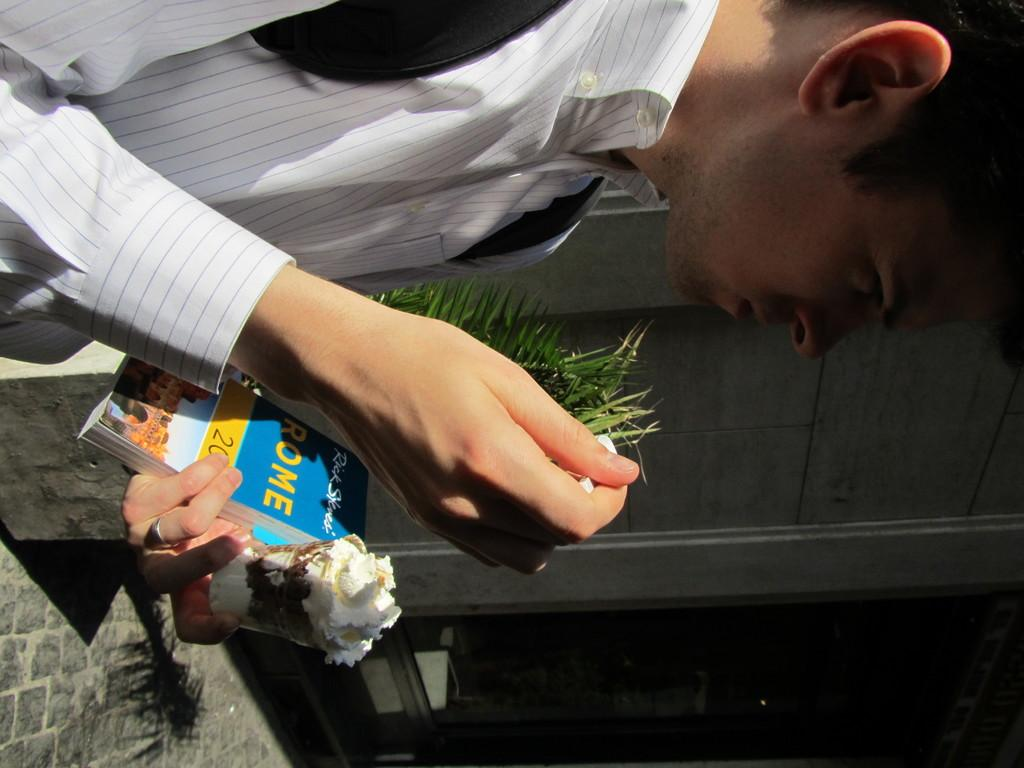What is the person in the image doing? The person is carrying a bag on his back, holding a book, an edible item, and a spoon in one hand, and there is a plant beside him. What is the person holding in his hand along with the book? The person is holding an edible item and a spoon in one hand. What is the plant beside the person? The facts do not specify the type of plant beside the person. How many items is the person holding in one hand? The person is holding three items in one hand: a book, an edible item, and a spoon. What time does the giraffe appear in the image? There is no giraffe present in the image. What is the person using the string for in the image? There is no mention of a string in the image. 